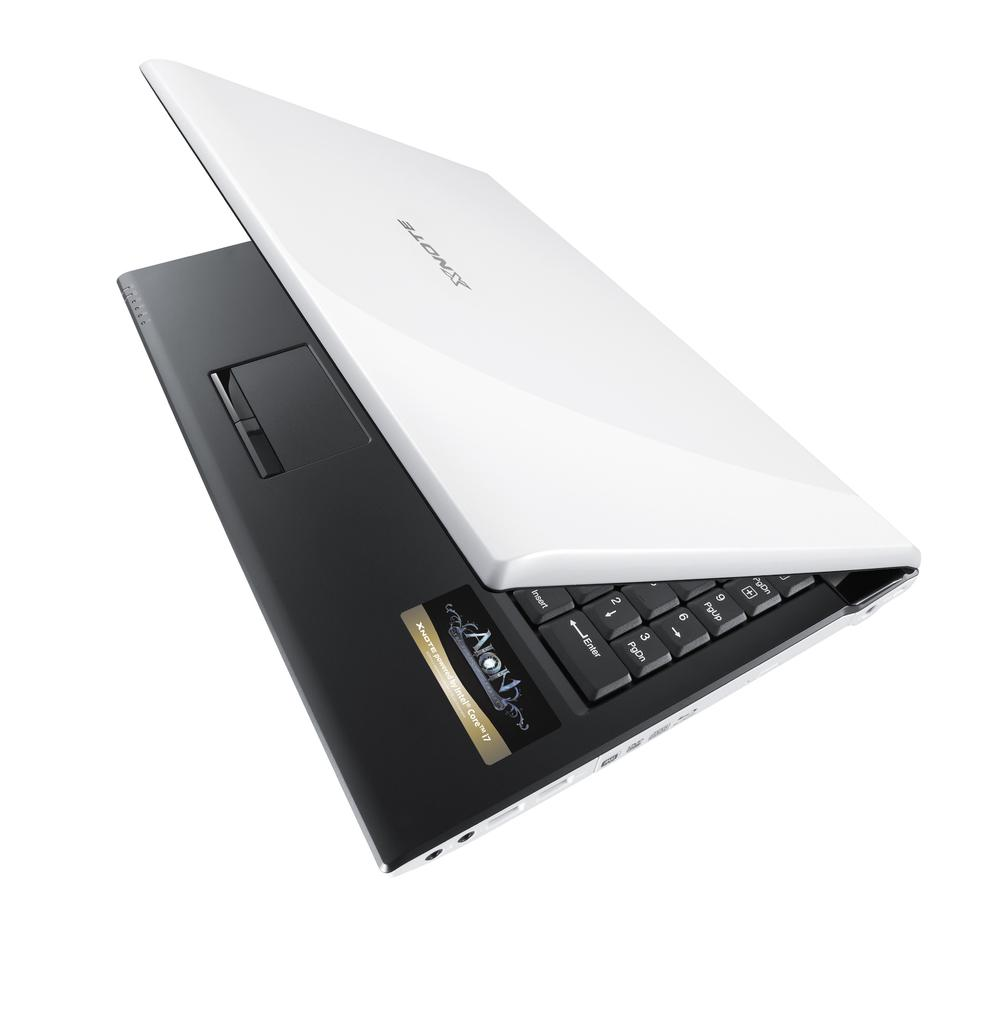<image>
Describe the image concisely. A laptop with the word Xnote written on the back 